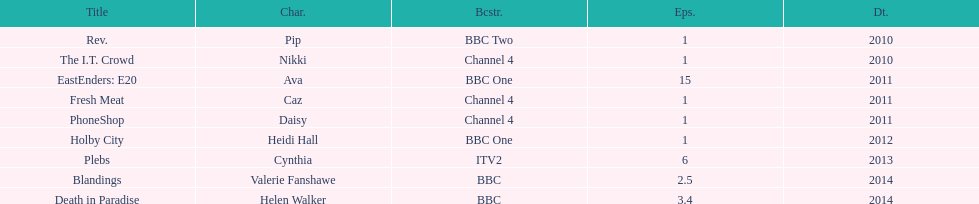Before assuming the role of cynthia in plebs, what character did this actress previously perform? Heidi Hall. 